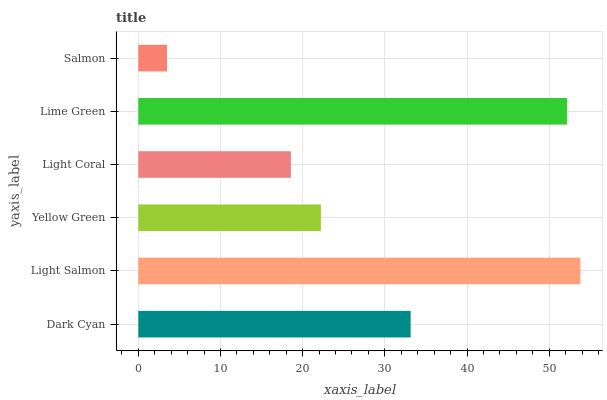Is Salmon the minimum?
Answer yes or no. Yes. Is Light Salmon the maximum?
Answer yes or no. Yes. Is Yellow Green the minimum?
Answer yes or no. No. Is Yellow Green the maximum?
Answer yes or no. No. Is Light Salmon greater than Yellow Green?
Answer yes or no. Yes. Is Yellow Green less than Light Salmon?
Answer yes or no. Yes. Is Yellow Green greater than Light Salmon?
Answer yes or no. No. Is Light Salmon less than Yellow Green?
Answer yes or no. No. Is Dark Cyan the high median?
Answer yes or no. Yes. Is Yellow Green the low median?
Answer yes or no. Yes. Is Lime Green the high median?
Answer yes or no. No. Is Light Coral the low median?
Answer yes or no. No. 